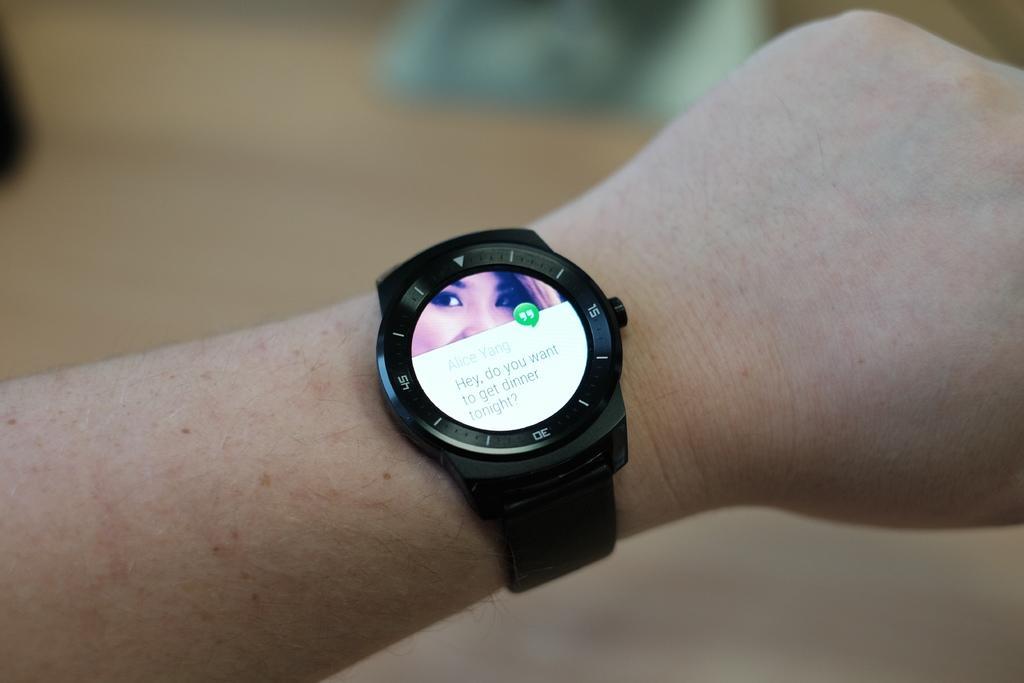Can you describe this image briefly? As we see in the image, there is a person wearing a wrist watch and on the dial of the wrist watch there are numbers 15, 30 and 45 and we see a screen on the watch and there is a woman picture on the first half and there is a message on the second half which says, Hey, do you want to get dinner tonight. 